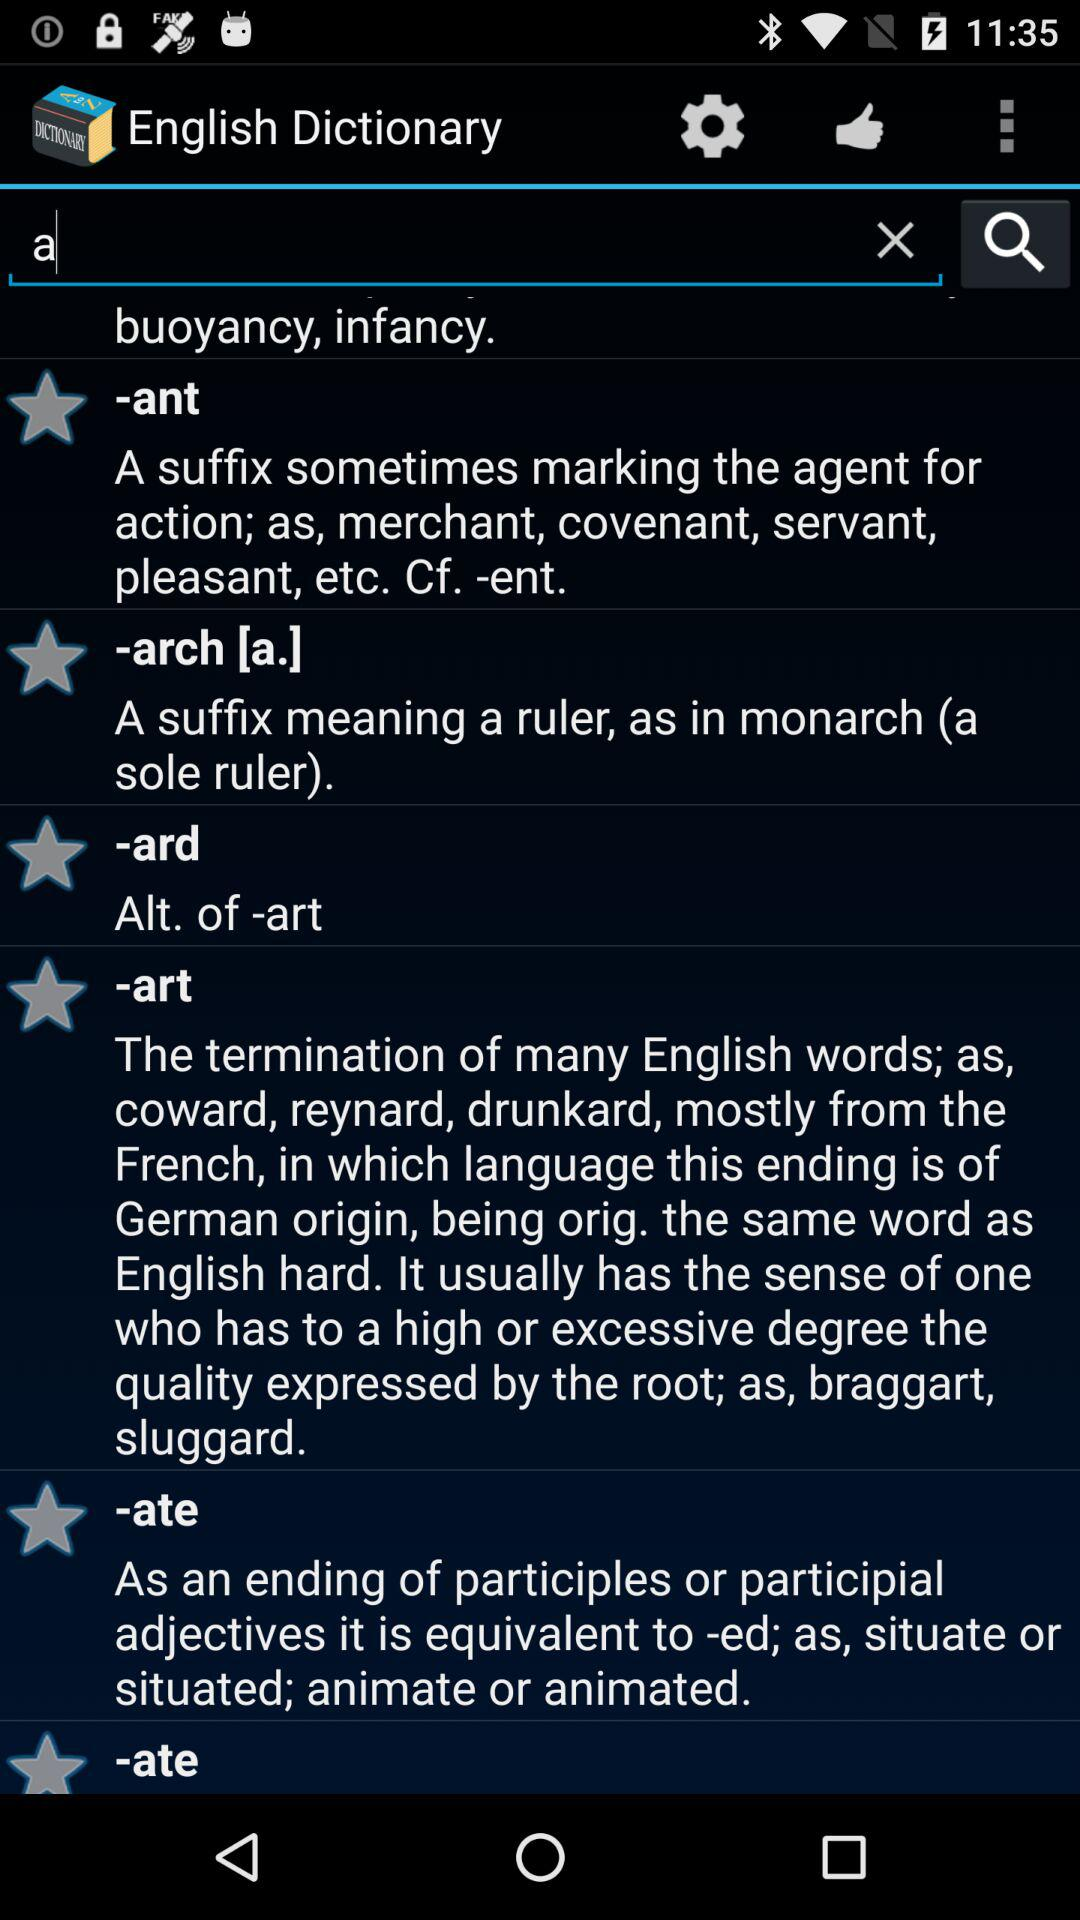The word sluggard is ended with which suffix?
When the provided information is insufficient, respond with <no answer>. <no answer> 